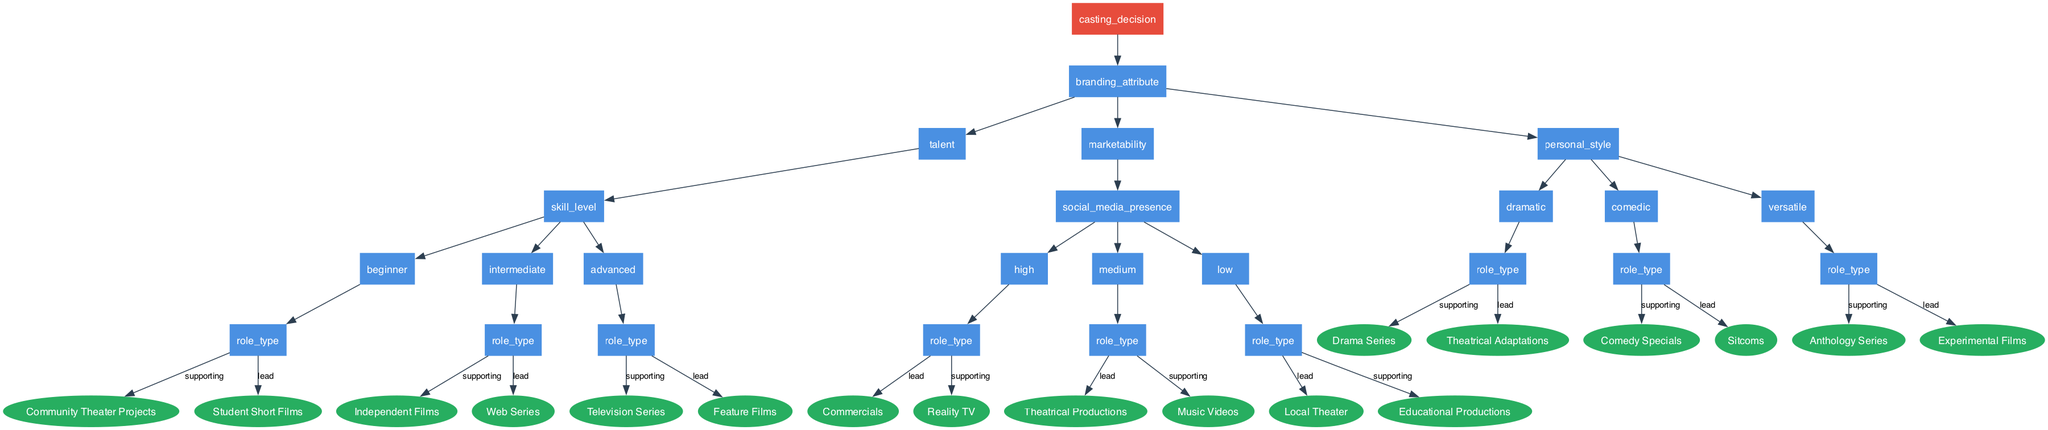What is the root node of the decision tree? The root node is the starting point of the diagram and it represents the main casting decision. Based on the structure of the diagram, the root node is "casting_decision."
Answer: casting_decision How many main branding attributes are present in the diagram? By examining the first level of nodes under the root node, there are three main branding attributes: talent, marketability, and personal_style. This can be counted directly from the diagram.
Answer: 3 What type of roles can a beginner with intermediate talent choose for a lead? Following the branches for a beginner skill level within the intermediate talent category, there would be no lead roles specified for this combination, but the lead role for the intermediate skill level is a web series. If a beginner has only access to student short films for lead roles in total, it indicates low skill level.
Answer: Student Short Films Which role type is available for an actor with high marketability in supporting roles? Under the high marketability node, the supporting role is classified as reality TV. This is specified directly within the supporting roles for high marketability.
Answer: Reality TV If an actor has a dramatic personal style, what is one potential lead role they can pursue? Looking at the dramatic personal style node leads directly to the notion that the lead role could be theatrical adaptations. This is the specified outcome at that stage of the tree.
Answer: Theatrical Adaptations What is the supporting role type for an actor classified as advanced in talent? At the advanced talent level, navigating to the supporting role leads us to the option of television series, which is clearly delineated at that level of the decision tree.
Answer: Television Series If an actor with medium social media presence wants a lead role, which option is available to them? Within the medium social media presence category, the diagram specifies that the available lead role is theatrical productions. By following the paths down through the nodes effectively leads to this conclusion.
Answer: Theatrical Productions In total, how many leaf nodes are there for supporting roles across all branding attributes? By analyzing the diagram, there are three leaf nodes for the supporting roles: community theater projects, independent films, and music videos, as well as others representing different attributes. Thus, counting all the leaf nodes leads us to the final tally for supporting roles.
Answer: 5 